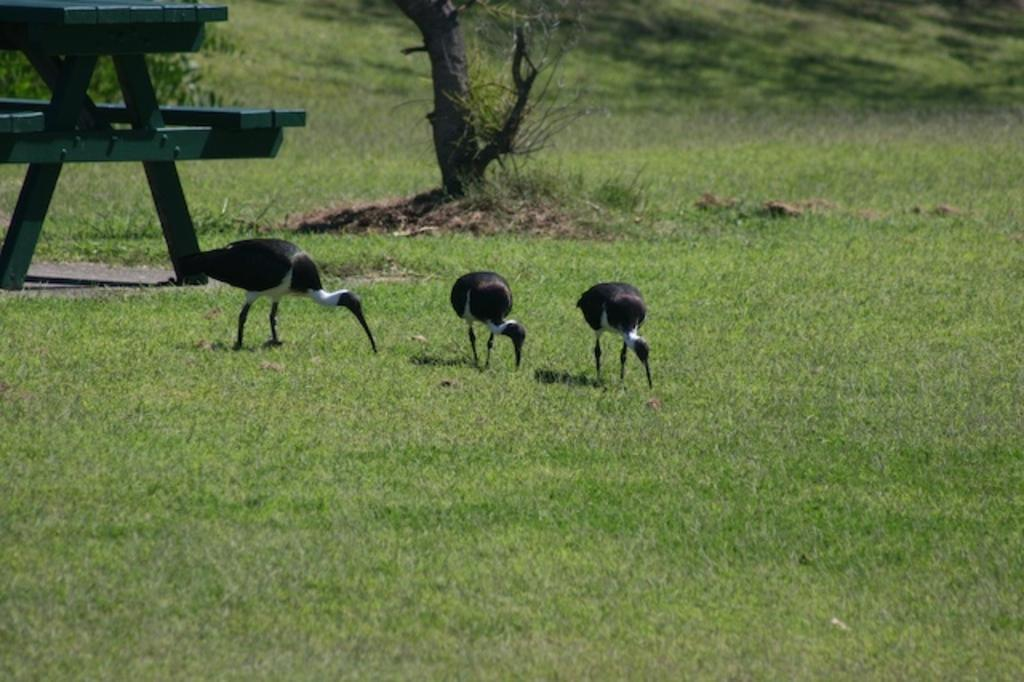How many birds are present in the image? There are three birds on the ground in the image. What is the color of the table in the image? The table in the image is green. What can be seen in the background of the image? There is a tree in the background of the image. What religious symbols can be seen on the birds in the image? There are no religious symbols present on the birds in the image. What type of ice can be seen melting on the table in the image? There is no ice present on the table in the image. 